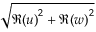Convert formula to latex. <formula><loc_0><loc_0><loc_500><loc_500>\sqrt { \Re { ( u ) } ^ { 2 } + \Re { ( w ) } ^ { 2 } }</formula> 